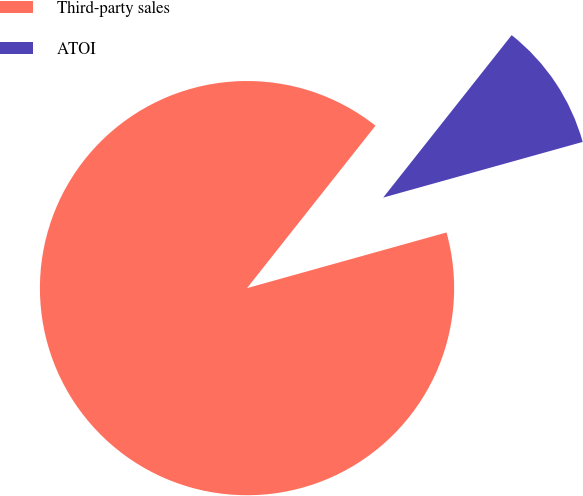Convert chart to OTSL. <chart><loc_0><loc_0><loc_500><loc_500><pie_chart><fcel>Third-party sales<fcel>ATOI<nl><fcel>89.98%<fcel>10.02%<nl></chart> 